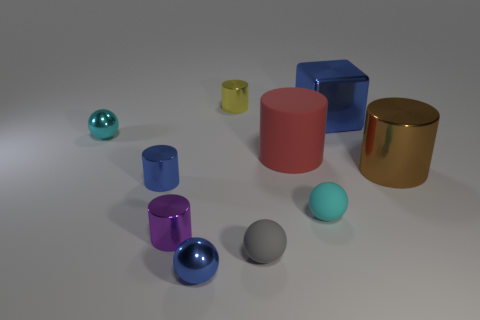Subtract all purple cylinders. How many cylinders are left? 4 Subtract all big metallic cylinders. How many cylinders are left? 4 Subtract 1 cylinders. How many cylinders are left? 4 Subtract all green cylinders. Subtract all blue balls. How many cylinders are left? 5 Subtract all spheres. How many objects are left? 6 Subtract 0 cyan cylinders. How many objects are left? 10 Subtract all green rubber blocks. Subtract all red matte objects. How many objects are left? 9 Add 7 big blue metal objects. How many big blue metal objects are left? 8 Add 4 gray spheres. How many gray spheres exist? 5 